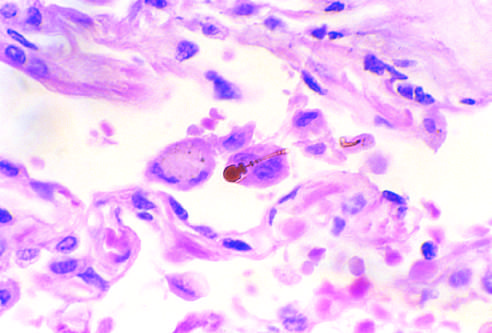did fatty streak in an experimental hypercholesterolemic rabbit reveal the typical beading and knobbed ends?
Answer the question using a single word or phrase. No 